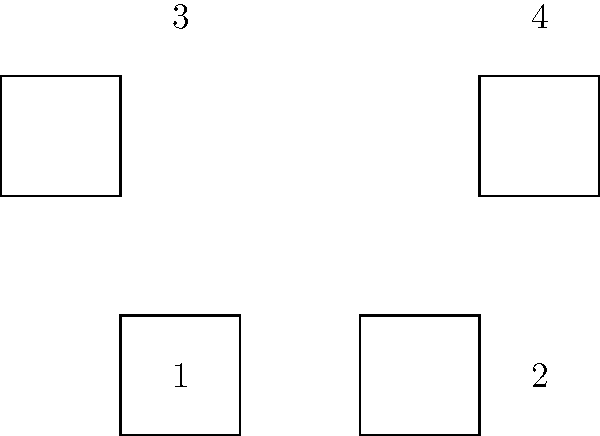Evelyn, remember when we used to solve puzzles together during our family gatherings in San Mateo? Here's a similar challenge for old times' sake. Look at the four squares labeled 1, 2, 3, and 4. Which two squares are identical when rotated? To solve this problem, we need to mentally rotate each square and compare them:

1. Square 1 is the reference square, oriented with a flat base.
2. Square 2 is rotated 90 degrees clockwise from Square 1.
3. Square 3 is rotated 180 degrees from Square 1 (or flipped upside down).
4. Square 4 is rotated 270 degrees clockwise from Square 1 (or 90 degrees counterclockwise).

When we mentally rotate these squares:
- Square 2, when rotated 270 degrees counterclockwise, matches Square 1.
- Square 3, when rotated 180 degrees, matches Square 1.
- Square 4, when rotated 90 degrees clockwise, matches Square 1.

Therefore, all four squares are actually identical when rotated appropriately. However, the question asks for two squares, so we can choose any pair.
Answer: Any two squares (e.g., 1 and 2) 